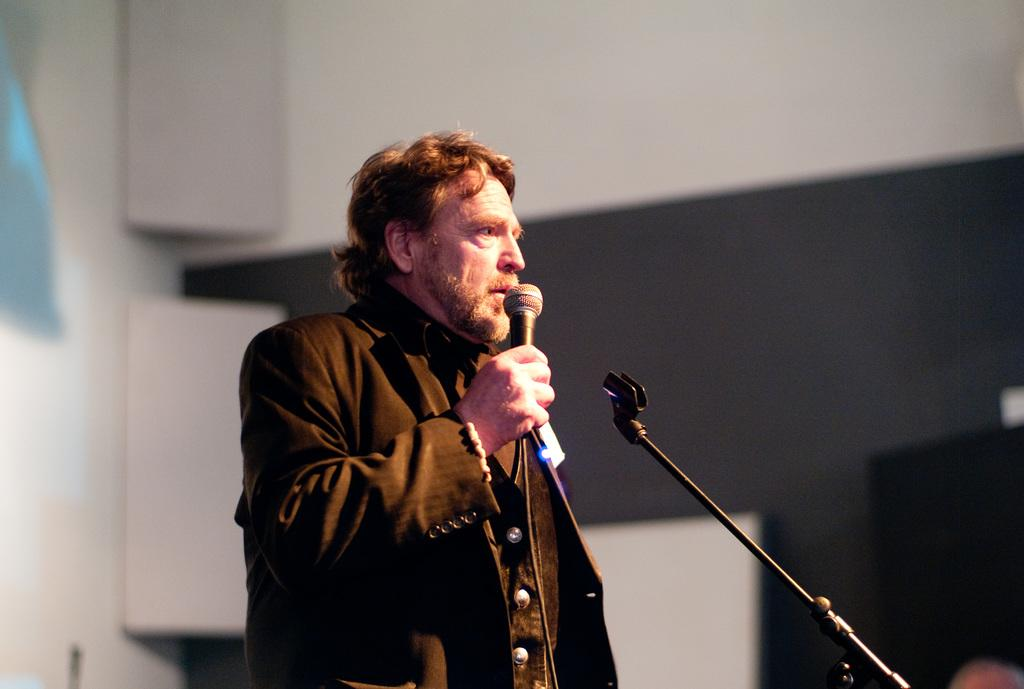What is the main subject of the image? The main subject of the image is a man. What is the man doing in the image? The man is standing in the image. What object is the man holding in the image? The man is holding a mic in the image. What is the purpose of the mic holder in the image? The mic holder is present in the image to hold the mic when it is not in use. What type of skin condition does the man have in the image? There is no indication of any skin condition in the image; the man's skin appears normal. What knowledge does the man possess about giants in the image? There is no mention of giants or any related knowledge in the image; the focus is on the man holding a mic. 